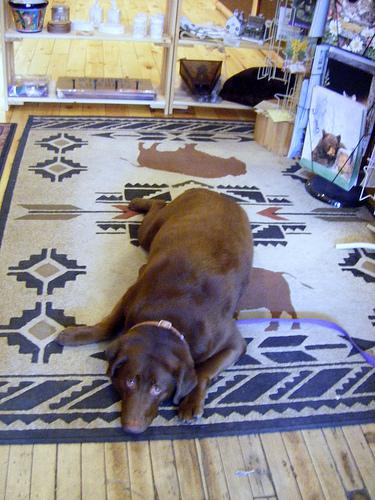Question: why is it there?
Choices:
A. Protection from the sun.
B. Keep man's head warm.
C. Resting.
D. Part of uniform.
Answer with the letter. Answer: C 